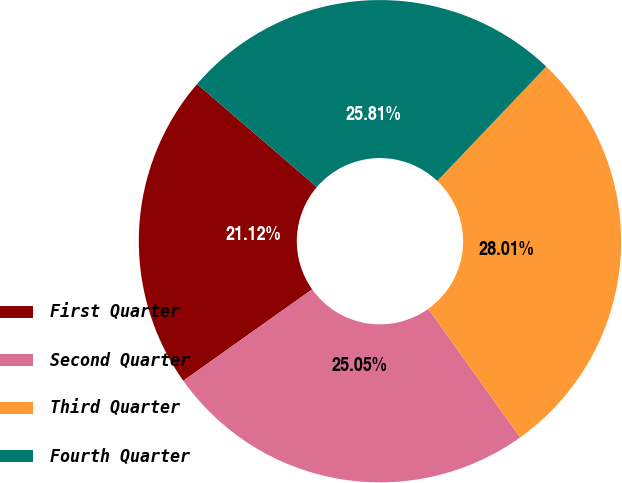Convert chart. <chart><loc_0><loc_0><loc_500><loc_500><pie_chart><fcel>First Quarter<fcel>Second Quarter<fcel>Third Quarter<fcel>Fourth Quarter<nl><fcel>21.12%<fcel>25.05%<fcel>28.01%<fcel>25.81%<nl></chart> 